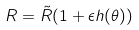Convert formula to latex. <formula><loc_0><loc_0><loc_500><loc_500>R = \tilde { R } ( 1 + \epsilon h ( \theta ) )</formula> 